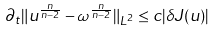<formula> <loc_0><loc_0><loc_500><loc_500>\partial _ { t } \| u ^ { \frac { n } { n - 2 } } - \omega ^ { \frac { n } { n - 2 } } \| _ { L ^ { 2 } } \leq c | \delta J ( u ) |</formula> 